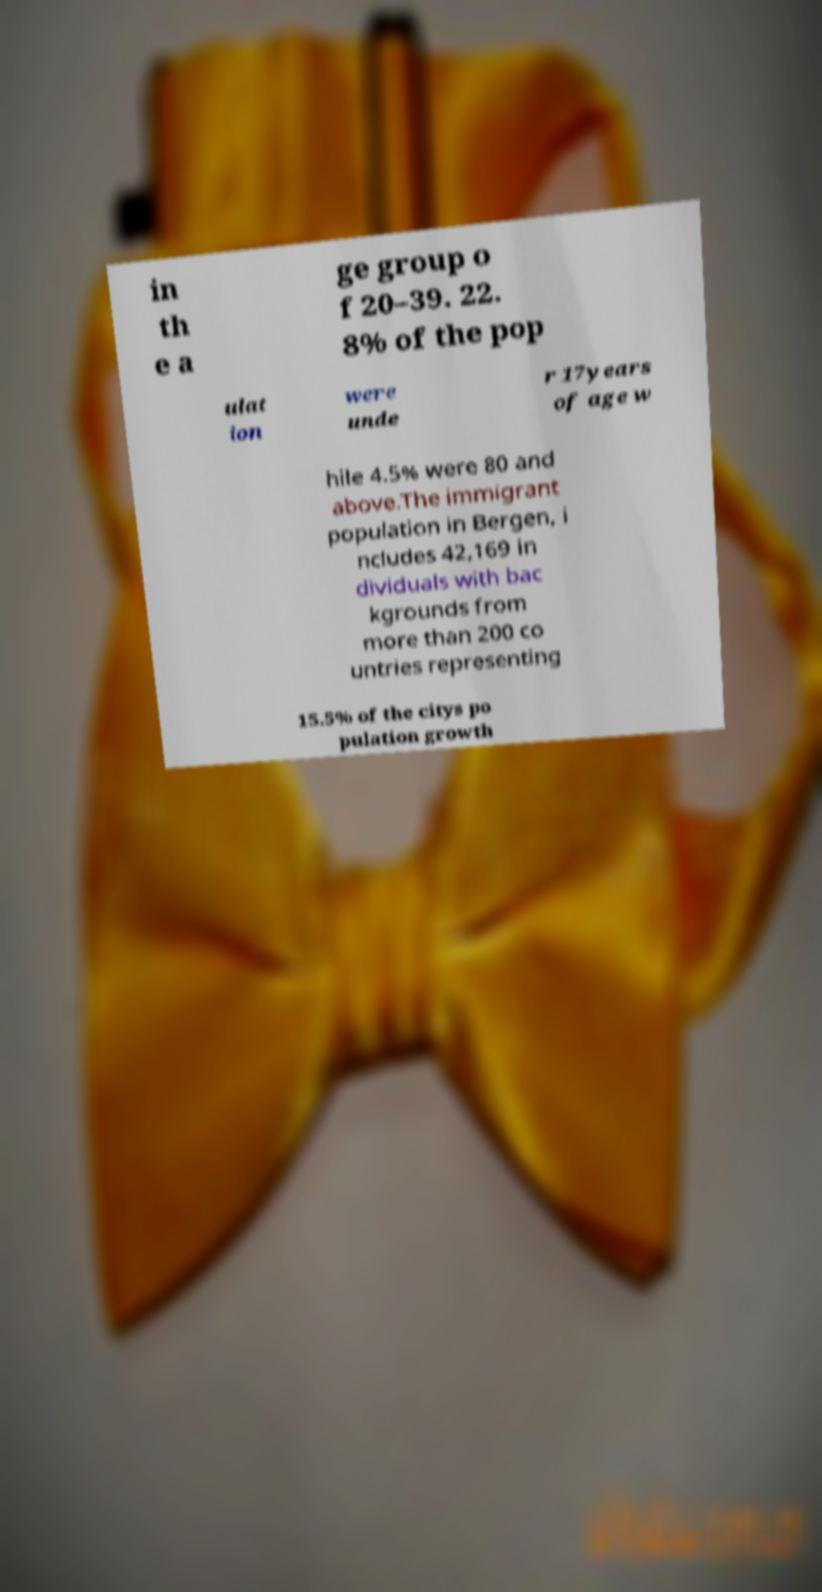Could you extract and type out the text from this image? in th e a ge group o f 20–39. 22. 8% of the pop ulat ion were unde r 17years of age w hile 4.5% were 80 and above.The immigrant population in Bergen, i ncludes 42,169 in dividuals with bac kgrounds from more than 200 co untries representing 15.5% of the citys po pulation growth 